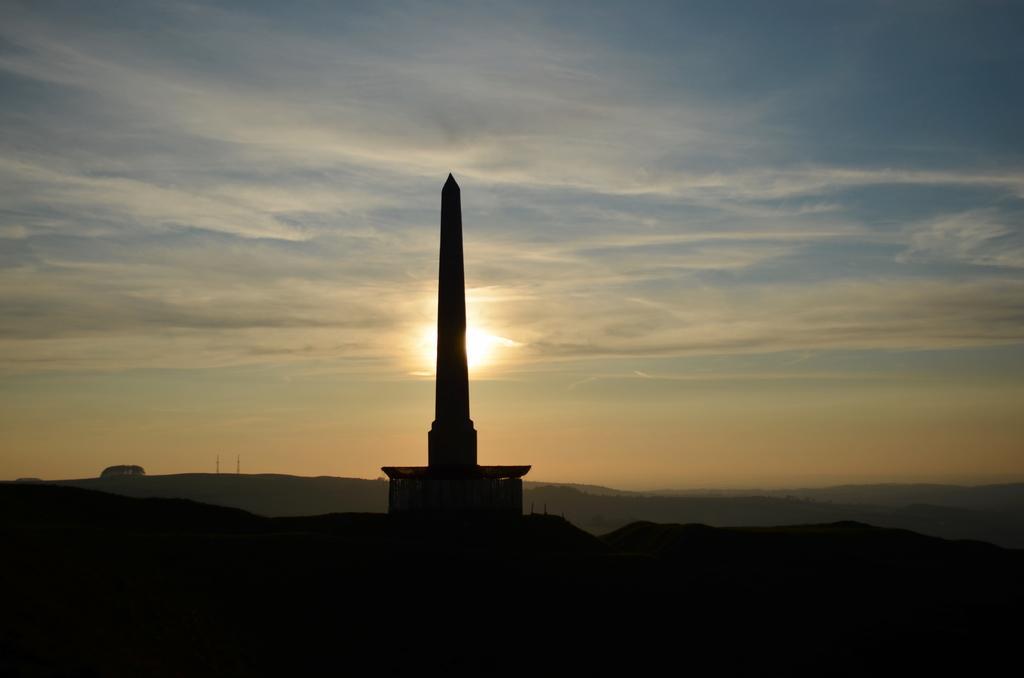Could you give a brief overview of what you see in this image? In the center of the image, we can see a tower and there are hills. In the background, there are clouds in the sky and we can see sunset. 